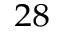Convert formula to latex. <formula><loc_0><loc_0><loc_500><loc_500>^ { 2 8 }</formula> 